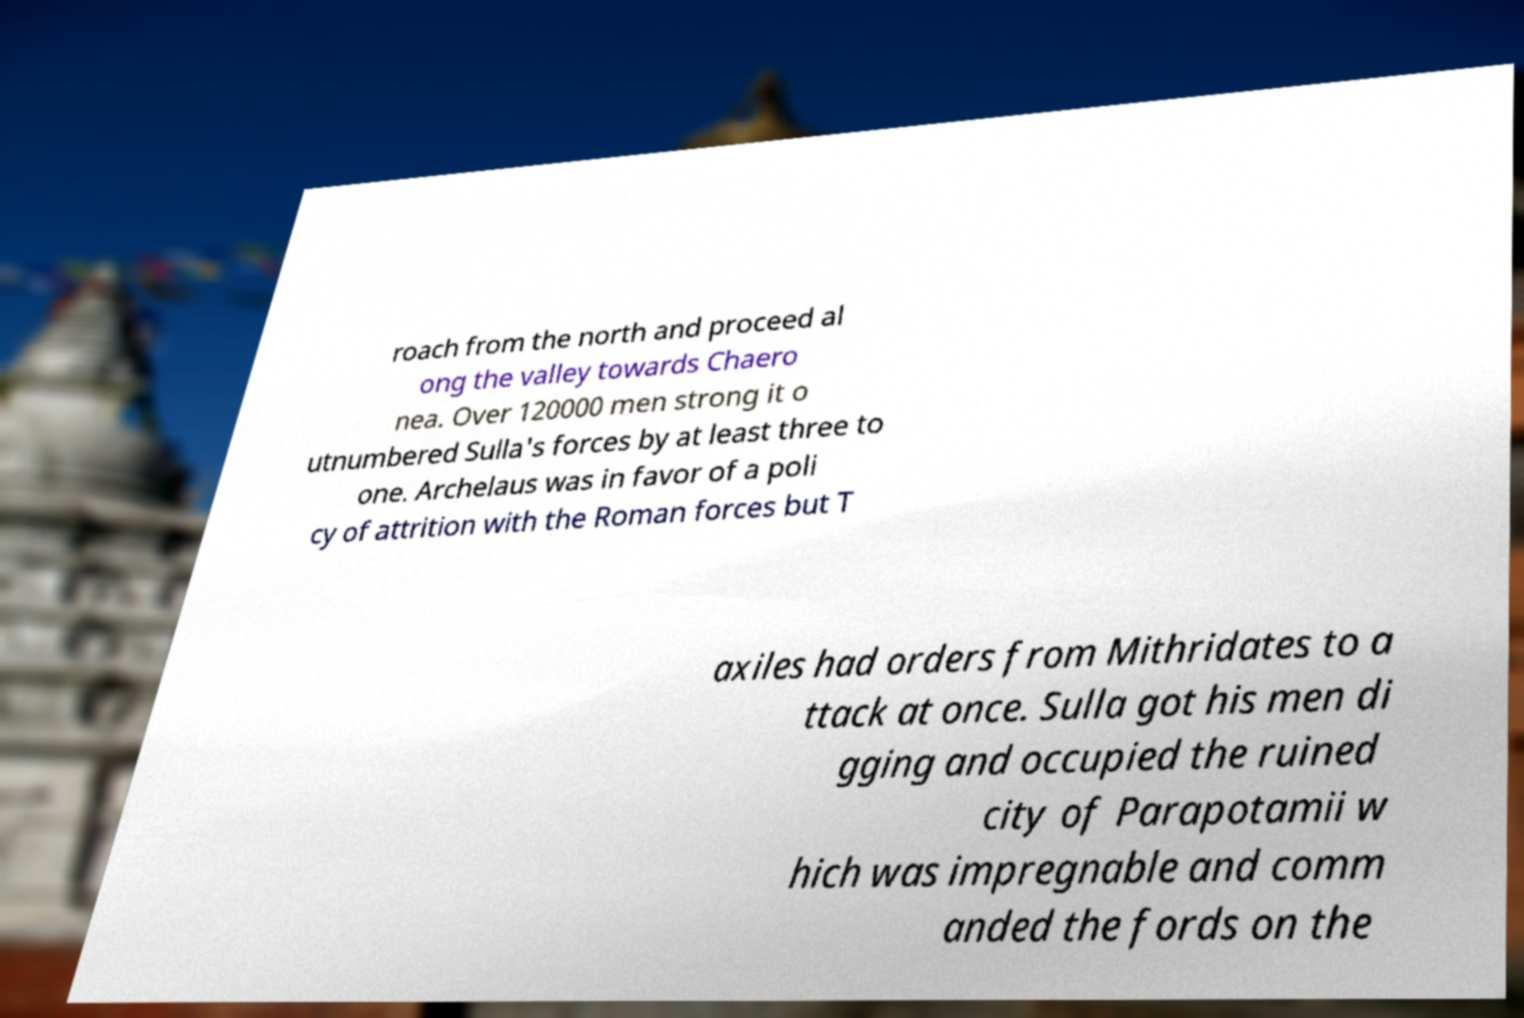Could you assist in decoding the text presented in this image and type it out clearly? roach from the north and proceed al ong the valley towards Chaero nea. Over 120000 men strong it o utnumbered Sulla's forces by at least three to one. Archelaus was in favor of a poli cy of attrition with the Roman forces but T axiles had orders from Mithridates to a ttack at once. Sulla got his men di gging and occupied the ruined city of Parapotamii w hich was impregnable and comm anded the fords on the 